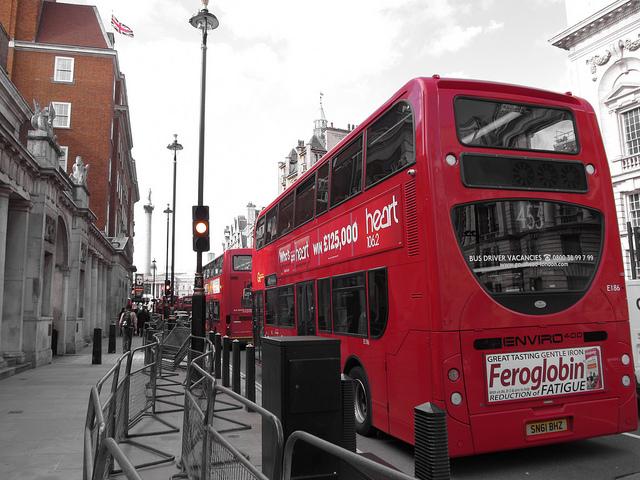Which language is written?
Concise answer only. English. What type of buses are these?
Quick response, please. Double decker. Is the picture colorful?
Give a very brief answer. Yes. What city is this in?
Keep it brief. London. What color is the street light?
Be succinct. Yellow. What event is the bus sign celebrating?
Short answer required. Feroglobin. What color stands out?
Short answer required. Red. Where is the bus parked?
Keep it brief. Street. What appendage is mentioned on the bus?
Answer briefly. Heart. What color is the closest house?
Short answer required. White. What are the words on the bus?
Quick response, please. Feroglobin. Which color is the bus?
Write a very short answer. Red. What color is the traffic light showing?
Answer briefly. Yellow. Is this bus used to transport people?
Quick response, please. Yes. What vehicle is this?
Write a very short answer. Bus. What color is the sign?
Write a very short answer. White. Are these tour buses?
Concise answer only. Yes. From whom does the bumper sticker ask for blessing?
Keep it brief. Feroglobin. Is there a sports team traveling in these busses?
Answer briefly. No. Is the train coming or going?
Answer briefly. Going. What language is on the front of this?
Answer briefly. English. Is there a tunnel ahead?
Concise answer only. No. What kind of bus is this?
Write a very short answer. Double decker. What are the people waiting for?
Short answer required. Bus. What color is the traffic signal?
Give a very brief answer. Yellow. Is this in China?
Give a very brief answer. No. How many sets of stairs are visible?
Concise answer only. 0. What does the back bus window say?
Answer briefly. Feroglobin. What colors are the train?
Be succinct. Red. What kind of vehicle is this?
Short answer required. Bus. Would cars stop or go based on the light?
Concise answer only. Stop. What has the bus been written?
Write a very short answer. Feroglobin. What color is the bus?
Give a very brief answer. Red. What is the name on the front of the train?
Answer briefly. Feroglobin. Does this bus belong to an international travel agency?
Be succinct. No. What website is written here?
Keep it brief. Feroglobin. What company is on the sign behind the bus?
Be succinct. Feroglobin. What type of vehicle?
Be succinct. Bus. Why are the vehicles stopped?
Be succinct. Traffic. Are the lights on the bus?
Keep it brief. No. What is the bus company's name?
Write a very short answer. Enviro. What is bright red?
Give a very brief answer. Bus. How many windows are on the bus?
Quick response, please. Many. Why is the bus red?
Write a very short answer. Because that is company's color. 